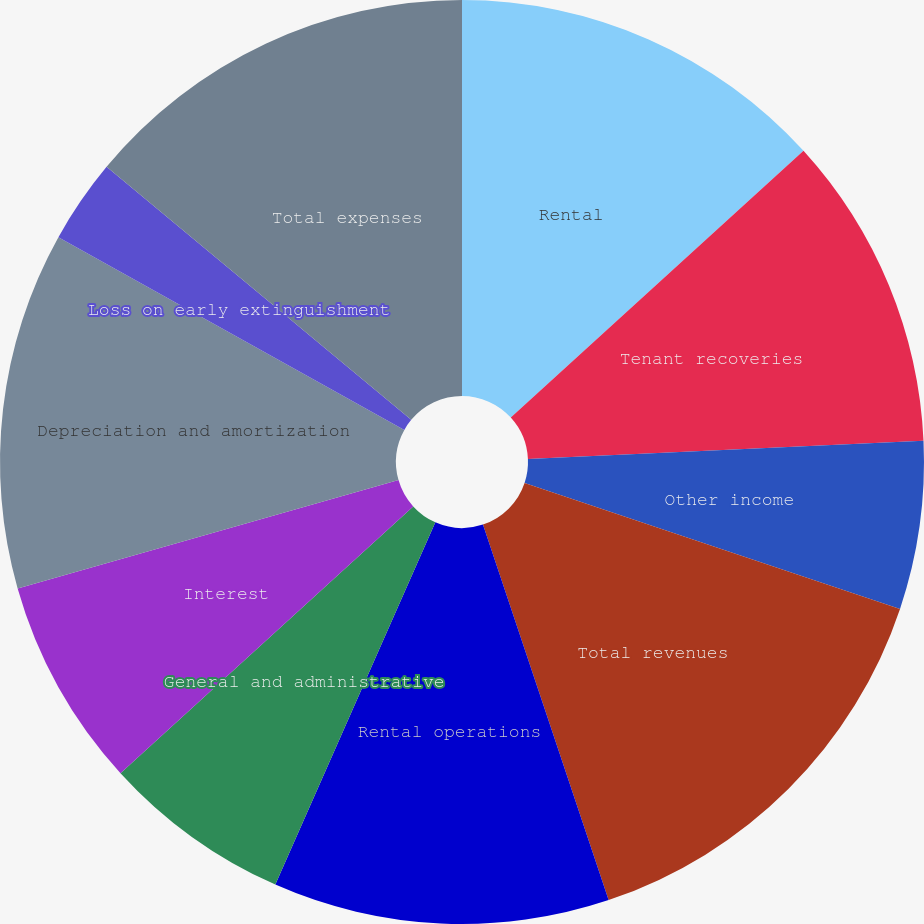<chart> <loc_0><loc_0><loc_500><loc_500><pie_chart><fcel>Rental<fcel>Tenant recoveries<fcel>Other income<fcel>Total revenues<fcel>Rental operations<fcel>General and administrative<fcel>Interest<fcel>Depreciation and amortization<fcel>Loss on early extinguishment<fcel>Total expenses<nl><fcel>13.24%<fcel>11.03%<fcel>5.88%<fcel>14.71%<fcel>11.76%<fcel>6.62%<fcel>7.35%<fcel>12.5%<fcel>2.94%<fcel>13.97%<nl></chart> 